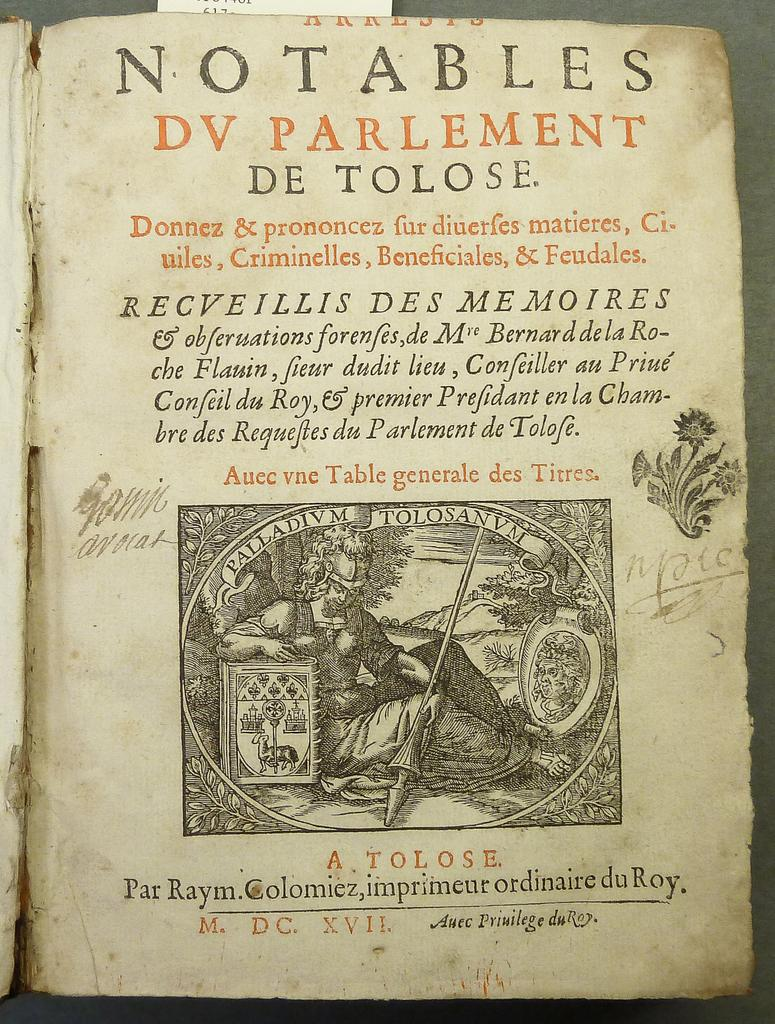What is the main subject in the foreground of the image? There is a page of a book in the foreground of the image. What can be found on the page of the book? The page contains an image and text. Where is the page of the book located? The page is on a surface. What type of bag is visible in the image? There is no bag present in the image. On which channel can the image be found? The image is not a part of a television channel; it is a static image. 